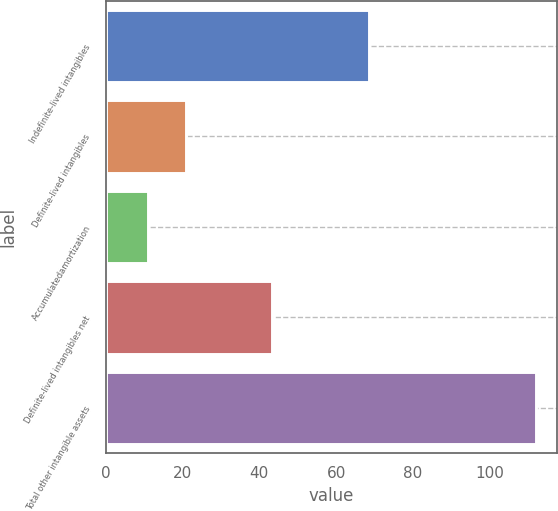<chart> <loc_0><loc_0><loc_500><loc_500><bar_chart><fcel>Indefinite-lived intangibles<fcel>Definite-lived intangibles<fcel>Accumulatedamortization<fcel>Definite-lived intangibles net<fcel>Total other intangible assets<nl><fcel>68.6<fcel>21<fcel>10.9<fcel>43.3<fcel>111.9<nl></chart> 